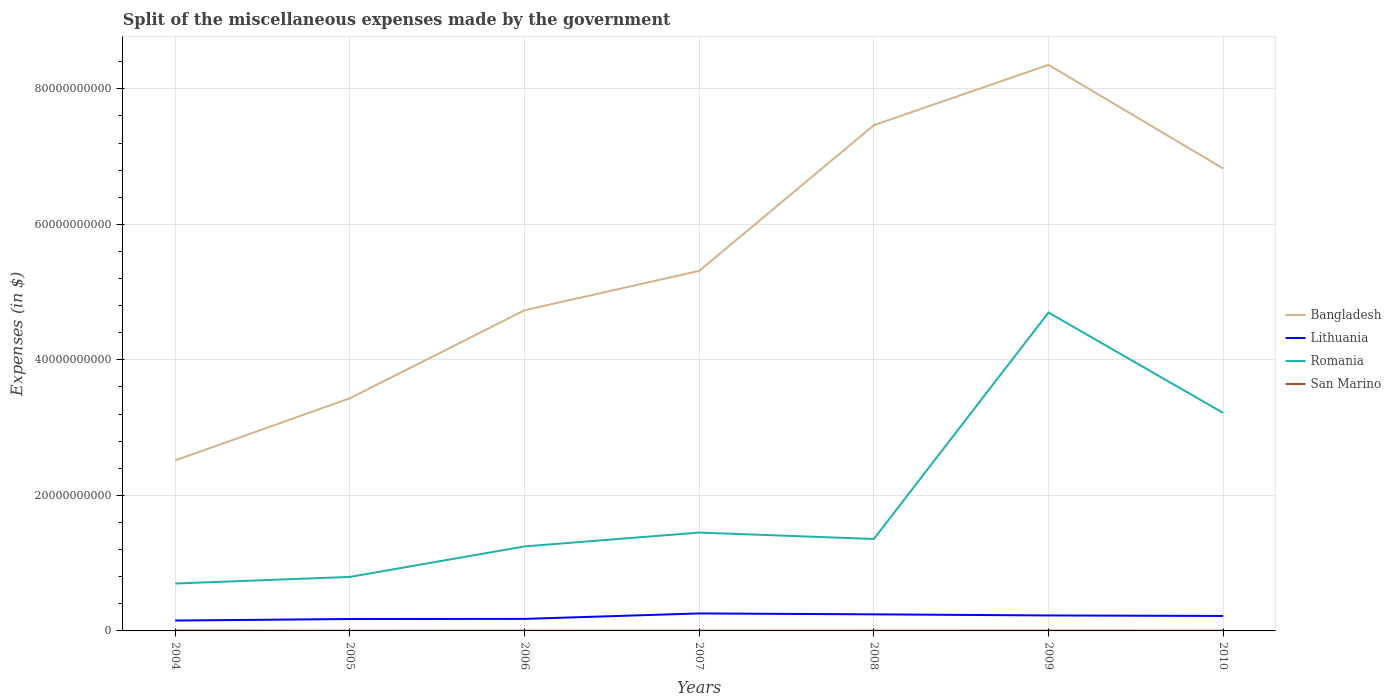How many different coloured lines are there?
Give a very brief answer. 4. Does the line corresponding to San Marino intersect with the line corresponding to Romania?
Provide a succinct answer. No. Is the number of lines equal to the number of legend labels?
Offer a terse response. Yes. Across all years, what is the maximum miscellaneous expenses made by the government in Bangladesh?
Offer a terse response. 2.52e+1. In which year was the miscellaneous expenses made by the government in Lithuania maximum?
Provide a succinct answer. 2004. What is the total miscellaneous expenses made by the government in Lithuania in the graph?
Offer a very short reply. -8.07e+08. What is the difference between the highest and the second highest miscellaneous expenses made by the government in San Marino?
Keep it short and to the point. 2.70e+07. What is the difference between the highest and the lowest miscellaneous expenses made by the government in Lithuania?
Your answer should be very brief. 4. How many lines are there?
Provide a succinct answer. 4. Does the graph contain any zero values?
Your answer should be very brief. No. Does the graph contain grids?
Give a very brief answer. Yes. How are the legend labels stacked?
Your response must be concise. Vertical. What is the title of the graph?
Give a very brief answer. Split of the miscellaneous expenses made by the government. What is the label or title of the X-axis?
Your answer should be compact. Years. What is the label or title of the Y-axis?
Your answer should be very brief. Expenses (in $). What is the Expenses (in $) of Bangladesh in 2004?
Your answer should be very brief. 2.52e+1. What is the Expenses (in $) in Lithuania in 2004?
Give a very brief answer. 1.53e+09. What is the Expenses (in $) in Romania in 2004?
Offer a very short reply. 6.99e+09. What is the Expenses (in $) in San Marino in 2004?
Your answer should be very brief. 5.65e+07. What is the Expenses (in $) of Bangladesh in 2005?
Make the answer very short. 3.43e+1. What is the Expenses (in $) of Lithuania in 2005?
Offer a terse response. 1.75e+09. What is the Expenses (in $) of Romania in 2005?
Provide a short and direct response. 7.97e+09. What is the Expenses (in $) in San Marino in 2005?
Offer a terse response. 2.95e+07. What is the Expenses (in $) of Bangladesh in 2006?
Give a very brief answer. 4.73e+1. What is the Expenses (in $) of Lithuania in 2006?
Your answer should be very brief. 1.78e+09. What is the Expenses (in $) of Romania in 2006?
Your response must be concise. 1.25e+1. What is the Expenses (in $) of San Marino in 2006?
Offer a terse response. 3.73e+07. What is the Expenses (in $) of Bangladesh in 2007?
Your answer should be very brief. 5.31e+1. What is the Expenses (in $) in Lithuania in 2007?
Your answer should be compact. 2.58e+09. What is the Expenses (in $) in Romania in 2007?
Offer a terse response. 1.45e+1. What is the Expenses (in $) of San Marino in 2007?
Your answer should be compact. 3.50e+07. What is the Expenses (in $) of Bangladesh in 2008?
Keep it short and to the point. 7.46e+1. What is the Expenses (in $) in Lithuania in 2008?
Your response must be concise. 2.45e+09. What is the Expenses (in $) of Romania in 2008?
Your answer should be compact. 1.36e+1. What is the Expenses (in $) in San Marino in 2008?
Your answer should be compact. 3.81e+07. What is the Expenses (in $) in Bangladesh in 2009?
Make the answer very short. 8.35e+1. What is the Expenses (in $) in Lithuania in 2009?
Provide a succinct answer. 2.28e+09. What is the Expenses (in $) in Romania in 2009?
Give a very brief answer. 4.70e+1. What is the Expenses (in $) in San Marino in 2009?
Your response must be concise. 4.16e+07. What is the Expenses (in $) in Bangladesh in 2010?
Offer a very short reply. 6.82e+1. What is the Expenses (in $) of Lithuania in 2010?
Provide a succinct answer. 2.21e+09. What is the Expenses (in $) of Romania in 2010?
Give a very brief answer. 3.22e+1. What is the Expenses (in $) in San Marino in 2010?
Your response must be concise. 4.00e+07. Across all years, what is the maximum Expenses (in $) in Bangladesh?
Keep it short and to the point. 8.35e+1. Across all years, what is the maximum Expenses (in $) in Lithuania?
Keep it short and to the point. 2.58e+09. Across all years, what is the maximum Expenses (in $) in Romania?
Provide a short and direct response. 4.70e+1. Across all years, what is the maximum Expenses (in $) of San Marino?
Make the answer very short. 5.65e+07. Across all years, what is the minimum Expenses (in $) in Bangladesh?
Your answer should be compact. 2.52e+1. Across all years, what is the minimum Expenses (in $) of Lithuania?
Your response must be concise. 1.53e+09. Across all years, what is the minimum Expenses (in $) of Romania?
Provide a short and direct response. 6.99e+09. Across all years, what is the minimum Expenses (in $) of San Marino?
Your answer should be very brief. 2.95e+07. What is the total Expenses (in $) of Bangladesh in the graph?
Ensure brevity in your answer.  3.86e+11. What is the total Expenses (in $) in Lithuania in the graph?
Offer a very short reply. 1.46e+1. What is the total Expenses (in $) in Romania in the graph?
Offer a very short reply. 1.35e+11. What is the total Expenses (in $) of San Marino in the graph?
Make the answer very short. 2.78e+08. What is the difference between the Expenses (in $) of Bangladesh in 2004 and that in 2005?
Offer a terse response. -9.17e+09. What is the difference between the Expenses (in $) in Lithuania in 2004 and that in 2005?
Keep it short and to the point. -2.23e+08. What is the difference between the Expenses (in $) of Romania in 2004 and that in 2005?
Offer a very short reply. -9.76e+08. What is the difference between the Expenses (in $) of San Marino in 2004 and that in 2005?
Make the answer very short. 2.70e+07. What is the difference between the Expenses (in $) of Bangladesh in 2004 and that in 2006?
Your response must be concise. -2.22e+1. What is the difference between the Expenses (in $) in Lithuania in 2004 and that in 2006?
Provide a short and direct response. -2.45e+08. What is the difference between the Expenses (in $) in Romania in 2004 and that in 2006?
Provide a short and direct response. -5.48e+09. What is the difference between the Expenses (in $) of San Marino in 2004 and that in 2006?
Provide a succinct answer. 1.92e+07. What is the difference between the Expenses (in $) of Bangladesh in 2004 and that in 2007?
Offer a terse response. -2.80e+1. What is the difference between the Expenses (in $) of Lithuania in 2004 and that in 2007?
Provide a succinct answer. -1.05e+09. What is the difference between the Expenses (in $) of Romania in 2004 and that in 2007?
Your answer should be compact. -7.52e+09. What is the difference between the Expenses (in $) of San Marino in 2004 and that in 2007?
Your response must be concise. 2.15e+07. What is the difference between the Expenses (in $) of Bangladesh in 2004 and that in 2008?
Provide a succinct answer. -4.95e+1. What is the difference between the Expenses (in $) in Lithuania in 2004 and that in 2008?
Make the answer very short. -9.16e+08. What is the difference between the Expenses (in $) in Romania in 2004 and that in 2008?
Make the answer very short. -6.57e+09. What is the difference between the Expenses (in $) in San Marino in 2004 and that in 2008?
Your answer should be very brief. 1.83e+07. What is the difference between the Expenses (in $) of Bangladesh in 2004 and that in 2009?
Offer a terse response. -5.84e+1. What is the difference between the Expenses (in $) in Lithuania in 2004 and that in 2009?
Provide a succinct answer. -7.53e+08. What is the difference between the Expenses (in $) of Romania in 2004 and that in 2009?
Keep it short and to the point. -4.00e+1. What is the difference between the Expenses (in $) of San Marino in 2004 and that in 2009?
Ensure brevity in your answer.  1.49e+07. What is the difference between the Expenses (in $) of Bangladesh in 2004 and that in 2010?
Ensure brevity in your answer.  -4.31e+1. What is the difference between the Expenses (in $) of Lithuania in 2004 and that in 2010?
Your response must be concise. -6.78e+08. What is the difference between the Expenses (in $) of Romania in 2004 and that in 2010?
Provide a succinct answer. -2.52e+1. What is the difference between the Expenses (in $) in San Marino in 2004 and that in 2010?
Provide a short and direct response. 1.65e+07. What is the difference between the Expenses (in $) in Bangladesh in 2005 and that in 2006?
Your answer should be compact. -1.30e+1. What is the difference between the Expenses (in $) of Lithuania in 2005 and that in 2006?
Offer a terse response. -2.16e+07. What is the difference between the Expenses (in $) in Romania in 2005 and that in 2006?
Your answer should be compact. -4.50e+09. What is the difference between the Expenses (in $) in San Marino in 2005 and that in 2006?
Your answer should be compact. -7.72e+06. What is the difference between the Expenses (in $) in Bangladesh in 2005 and that in 2007?
Your response must be concise. -1.88e+1. What is the difference between the Expenses (in $) of Lithuania in 2005 and that in 2007?
Your answer should be very brief. -8.28e+08. What is the difference between the Expenses (in $) of Romania in 2005 and that in 2007?
Ensure brevity in your answer.  -6.55e+09. What is the difference between the Expenses (in $) in San Marino in 2005 and that in 2007?
Provide a short and direct response. -5.46e+06. What is the difference between the Expenses (in $) of Bangladesh in 2005 and that in 2008?
Your answer should be very brief. -4.03e+1. What is the difference between the Expenses (in $) of Lithuania in 2005 and that in 2008?
Ensure brevity in your answer.  -6.93e+08. What is the difference between the Expenses (in $) in Romania in 2005 and that in 2008?
Make the answer very short. -5.60e+09. What is the difference between the Expenses (in $) of San Marino in 2005 and that in 2008?
Your answer should be very brief. -8.61e+06. What is the difference between the Expenses (in $) in Bangladesh in 2005 and that in 2009?
Your response must be concise. -4.92e+1. What is the difference between the Expenses (in $) in Lithuania in 2005 and that in 2009?
Provide a short and direct response. -5.29e+08. What is the difference between the Expenses (in $) of Romania in 2005 and that in 2009?
Keep it short and to the point. -3.90e+1. What is the difference between the Expenses (in $) of San Marino in 2005 and that in 2009?
Make the answer very short. -1.21e+07. What is the difference between the Expenses (in $) of Bangladesh in 2005 and that in 2010?
Offer a terse response. -3.39e+1. What is the difference between the Expenses (in $) of Lithuania in 2005 and that in 2010?
Ensure brevity in your answer.  -4.54e+08. What is the difference between the Expenses (in $) of Romania in 2005 and that in 2010?
Give a very brief answer. -2.42e+1. What is the difference between the Expenses (in $) in San Marino in 2005 and that in 2010?
Provide a short and direct response. -1.05e+07. What is the difference between the Expenses (in $) in Bangladesh in 2006 and that in 2007?
Your answer should be compact. -5.81e+09. What is the difference between the Expenses (in $) in Lithuania in 2006 and that in 2007?
Make the answer very short. -8.07e+08. What is the difference between the Expenses (in $) of Romania in 2006 and that in 2007?
Provide a succinct answer. -2.04e+09. What is the difference between the Expenses (in $) of San Marino in 2006 and that in 2007?
Your answer should be compact. 2.26e+06. What is the difference between the Expenses (in $) of Bangladesh in 2006 and that in 2008?
Your answer should be very brief. -2.73e+1. What is the difference between the Expenses (in $) in Lithuania in 2006 and that in 2008?
Your answer should be very brief. -6.71e+08. What is the difference between the Expenses (in $) of Romania in 2006 and that in 2008?
Ensure brevity in your answer.  -1.10e+09. What is the difference between the Expenses (in $) in San Marino in 2006 and that in 2008?
Your answer should be very brief. -8.90e+05. What is the difference between the Expenses (in $) of Bangladesh in 2006 and that in 2009?
Your response must be concise. -3.62e+1. What is the difference between the Expenses (in $) in Lithuania in 2006 and that in 2009?
Your answer should be compact. -5.08e+08. What is the difference between the Expenses (in $) of Romania in 2006 and that in 2009?
Offer a very short reply. -3.45e+1. What is the difference between the Expenses (in $) in San Marino in 2006 and that in 2009?
Your response must be concise. -4.37e+06. What is the difference between the Expenses (in $) in Bangladesh in 2006 and that in 2010?
Your answer should be compact. -2.09e+1. What is the difference between the Expenses (in $) in Lithuania in 2006 and that in 2010?
Provide a short and direct response. -4.33e+08. What is the difference between the Expenses (in $) of Romania in 2006 and that in 2010?
Your answer should be compact. -1.97e+1. What is the difference between the Expenses (in $) in San Marino in 2006 and that in 2010?
Ensure brevity in your answer.  -2.76e+06. What is the difference between the Expenses (in $) of Bangladesh in 2007 and that in 2008?
Offer a very short reply. -2.15e+1. What is the difference between the Expenses (in $) in Lithuania in 2007 and that in 2008?
Make the answer very short. 1.36e+08. What is the difference between the Expenses (in $) in Romania in 2007 and that in 2008?
Make the answer very short. 9.48e+08. What is the difference between the Expenses (in $) of San Marino in 2007 and that in 2008?
Keep it short and to the point. -3.15e+06. What is the difference between the Expenses (in $) in Bangladesh in 2007 and that in 2009?
Make the answer very short. -3.04e+1. What is the difference between the Expenses (in $) of Lithuania in 2007 and that in 2009?
Keep it short and to the point. 2.99e+08. What is the difference between the Expenses (in $) of Romania in 2007 and that in 2009?
Make the answer very short. -3.25e+1. What is the difference between the Expenses (in $) of San Marino in 2007 and that in 2009?
Keep it short and to the point. -6.63e+06. What is the difference between the Expenses (in $) in Bangladesh in 2007 and that in 2010?
Your answer should be compact. -1.51e+1. What is the difference between the Expenses (in $) in Lithuania in 2007 and that in 2010?
Your answer should be very brief. 3.74e+08. What is the difference between the Expenses (in $) in Romania in 2007 and that in 2010?
Your answer should be very brief. -1.77e+1. What is the difference between the Expenses (in $) of San Marino in 2007 and that in 2010?
Offer a very short reply. -5.02e+06. What is the difference between the Expenses (in $) of Bangladesh in 2008 and that in 2009?
Give a very brief answer. -8.90e+09. What is the difference between the Expenses (in $) of Lithuania in 2008 and that in 2009?
Make the answer very short. 1.64e+08. What is the difference between the Expenses (in $) of Romania in 2008 and that in 2009?
Provide a short and direct response. -3.34e+1. What is the difference between the Expenses (in $) in San Marino in 2008 and that in 2009?
Give a very brief answer. -3.48e+06. What is the difference between the Expenses (in $) in Bangladesh in 2008 and that in 2010?
Make the answer very short. 6.39e+09. What is the difference between the Expenses (in $) in Lithuania in 2008 and that in 2010?
Your answer should be compact. 2.38e+08. What is the difference between the Expenses (in $) in Romania in 2008 and that in 2010?
Give a very brief answer. -1.86e+1. What is the difference between the Expenses (in $) of San Marino in 2008 and that in 2010?
Offer a very short reply. -1.87e+06. What is the difference between the Expenses (in $) of Bangladesh in 2009 and that in 2010?
Provide a short and direct response. 1.53e+1. What is the difference between the Expenses (in $) of Lithuania in 2009 and that in 2010?
Offer a very short reply. 7.48e+07. What is the difference between the Expenses (in $) in Romania in 2009 and that in 2010?
Provide a short and direct response. 1.48e+1. What is the difference between the Expenses (in $) in San Marino in 2009 and that in 2010?
Make the answer very short. 1.61e+06. What is the difference between the Expenses (in $) of Bangladesh in 2004 and the Expenses (in $) of Lithuania in 2005?
Your response must be concise. 2.34e+1. What is the difference between the Expenses (in $) in Bangladesh in 2004 and the Expenses (in $) in Romania in 2005?
Your response must be concise. 1.72e+1. What is the difference between the Expenses (in $) of Bangladesh in 2004 and the Expenses (in $) of San Marino in 2005?
Offer a terse response. 2.51e+1. What is the difference between the Expenses (in $) in Lithuania in 2004 and the Expenses (in $) in Romania in 2005?
Offer a terse response. -6.44e+09. What is the difference between the Expenses (in $) in Lithuania in 2004 and the Expenses (in $) in San Marino in 2005?
Give a very brief answer. 1.50e+09. What is the difference between the Expenses (in $) of Romania in 2004 and the Expenses (in $) of San Marino in 2005?
Your answer should be compact. 6.96e+09. What is the difference between the Expenses (in $) of Bangladesh in 2004 and the Expenses (in $) of Lithuania in 2006?
Provide a short and direct response. 2.34e+1. What is the difference between the Expenses (in $) in Bangladesh in 2004 and the Expenses (in $) in Romania in 2006?
Offer a terse response. 1.27e+1. What is the difference between the Expenses (in $) in Bangladesh in 2004 and the Expenses (in $) in San Marino in 2006?
Keep it short and to the point. 2.51e+1. What is the difference between the Expenses (in $) of Lithuania in 2004 and the Expenses (in $) of Romania in 2006?
Offer a very short reply. -1.09e+1. What is the difference between the Expenses (in $) of Lithuania in 2004 and the Expenses (in $) of San Marino in 2006?
Offer a terse response. 1.49e+09. What is the difference between the Expenses (in $) of Romania in 2004 and the Expenses (in $) of San Marino in 2006?
Offer a very short reply. 6.96e+09. What is the difference between the Expenses (in $) in Bangladesh in 2004 and the Expenses (in $) in Lithuania in 2007?
Provide a succinct answer. 2.26e+1. What is the difference between the Expenses (in $) of Bangladesh in 2004 and the Expenses (in $) of Romania in 2007?
Keep it short and to the point. 1.06e+1. What is the difference between the Expenses (in $) in Bangladesh in 2004 and the Expenses (in $) in San Marino in 2007?
Your answer should be compact. 2.51e+1. What is the difference between the Expenses (in $) of Lithuania in 2004 and the Expenses (in $) of Romania in 2007?
Keep it short and to the point. -1.30e+1. What is the difference between the Expenses (in $) of Lithuania in 2004 and the Expenses (in $) of San Marino in 2007?
Make the answer very short. 1.50e+09. What is the difference between the Expenses (in $) in Romania in 2004 and the Expenses (in $) in San Marino in 2007?
Your answer should be compact. 6.96e+09. What is the difference between the Expenses (in $) of Bangladesh in 2004 and the Expenses (in $) of Lithuania in 2008?
Offer a very short reply. 2.27e+1. What is the difference between the Expenses (in $) in Bangladesh in 2004 and the Expenses (in $) in Romania in 2008?
Your answer should be compact. 1.16e+1. What is the difference between the Expenses (in $) in Bangladesh in 2004 and the Expenses (in $) in San Marino in 2008?
Your answer should be very brief. 2.51e+1. What is the difference between the Expenses (in $) in Lithuania in 2004 and the Expenses (in $) in Romania in 2008?
Ensure brevity in your answer.  -1.20e+1. What is the difference between the Expenses (in $) of Lithuania in 2004 and the Expenses (in $) of San Marino in 2008?
Provide a succinct answer. 1.49e+09. What is the difference between the Expenses (in $) in Romania in 2004 and the Expenses (in $) in San Marino in 2008?
Provide a succinct answer. 6.96e+09. What is the difference between the Expenses (in $) in Bangladesh in 2004 and the Expenses (in $) in Lithuania in 2009?
Offer a terse response. 2.29e+1. What is the difference between the Expenses (in $) of Bangladesh in 2004 and the Expenses (in $) of Romania in 2009?
Offer a terse response. -2.18e+1. What is the difference between the Expenses (in $) of Bangladesh in 2004 and the Expenses (in $) of San Marino in 2009?
Make the answer very short. 2.51e+1. What is the difference between the Expenses (in $) of Lithuania in 2004 and the Expenses (in $) of Romania in 2009?
Offer a terse response. -4.55e+1. What is the difference between the Expenses (in $) of Lithuania in 2004 and the Expenses (in $) of San Marino in 2009?
Your answer should be very brief. 1.49e+09. What is the difference between the Expenses (in $) of Romania in 2004 and the Expenses (in $) of San Marino in 2009?
Provide a succinct answer. 6.95e+09. What is the difference between the Expenses (in $) in Bangladesh in 2004 and the Expenses (in $) in Lithuania in 2010?
Offer a very short reply. 2.30e+1. What is the difference between the Expenses (in $) in Bangladesh in 2004 and the Expenses (in $) in Romania in 2010?
Your response must be concise. -7.01e+09. What is the difference between the Expenses (in $) in Bangladesh in 2004 and the Expenses (in $) in San Marino in 2010?
Your answer should be compact. 2.51e+1. What is the difference between the Expenses (in $) in Lithuania in 2004 and the Expenses (in $) in Romania in 2010?
Your answer should be compact. -3.06e+1. What is the difference between the Expenses (in $) of Lithuania in 2004 and the Expenses (in $) of San Marino in 2010?
Provide a succinct answer. 1.49e+09. What is the difference between the Expenses (in $) in Romania in 2004 and the Expenses (in $) in San Marino in 2010?
Ensure brevity in your answer.  6.95e+09. What is the difference between the Expenses (in $) in Bangladesh in 2005 and the Expenses (in $) in Lithuania in 2006?
Your answer should be compact. 3.26e+1. What is the difference between the Expenses (in $) in Bangladesh in 2005 and the Expenses (in $) in Romania in 2006?
Offer a very short reply. 2.19e+1. What is the difference between the Expenses (in $) of Bangladesh in 2005 and the Expenses (in $) of San Marino in 2006?
Your answer should be compact. 3.43e+1. What is the difference between the Expenses (in $) in Lithuania in 2005 and the Expenses (in $) in Romania in 2006?
Ensure brevity in your answer.  -1.07e+1. What is the difference between the Expenses (in $) in Lithuania in 2005 and the Expenses (in $) in San Marino in 2006?
Provide a short and direct response. 1.72e+09. What is the difference between the Expenses (in $) of Romania in 2005 and the Expenses (in $) of San Marino in 2006?
Offer a very short reply. 7.93e+09. What is the difference between the Expenses (in $) in Bangladesh in 2005 and the Expenses (in $) in Lithuania in 2007?
Keep it short and to the point. 3.18e+1. What is the difference between the Expenses (in $) of Bangladesh in 2005 and the Expenses (in $) of Romania in 2007?
Your answer should be very brief. 1.98e+1. What is the difference between the Expenses (in $) in Bangladesh in 2005 and the Expenses (in $) in San Marino in 2007?
Offer a terse response. 3.43e+1. What is the difference between the Expenses (in $) of Lithuania in 2005 and the Expenses (in $) of Romania in 2007?
Provide a short and direct response. -1.28e+1. What is the difference between the Expenses (in $) in Lithuania in 2005 and the Expenses (in $) in San Marino in 2007?
Give a very brief answer. 1.72e+09. What is the difference between the Expenses (in $) of Romania in 2005 and the Expenses (in $) of San Marino in 2007?
Give a very brief answer. 7.94e+09. What is the difference between the Expenses (in $) of Bangladesh in 2005 and the Expenses (in $) of Lithuania in 2008?
Give a very brief answer. 3.19e+1. What is the difference between the Expenses (in $) of Bangladesh in 2005 and the Expenses (in $) of Romania in 2008?
Ensure brevity in your answer.  2.08e+1. What is the difference between the Expenses (in $) in Bangladesh in 2005 and the Expenses (in $) in San Marino in 2008?
Provide a succinct answer. 3.43e+1. What is the difference between the Expenses (in $) of Lithuania in 2005 and the Expenses (in $) of Romania in 2008?
Your answer should be very brief. -1.18e+1. What is the difference between the Expenses (in $) in Lithuania in 2005 and the Expenses (in $) in San Marino in 2008?
Make the answer very short. 1.72e+09. What is the difference between the Expenses (in $) in Romania in 2005 and the Expenses (in $) in San Marino in 2008?
Keep it short and to the point. 7.93e+09. What is the difference between the Expenses (in $) of Bangladesh in 2005 and the Expenses (in $) of Lithuania in 2009?
Keep it short and to the point. 3.21e+1. What is the difference between the Expenses (in $) of Bangladesh in 2005 and the Expenses (in $) of Romania in 2009?
Your response must be concise. -1.26e+1. What is the difference between the Expenses (in $) in Bangladesh in 2005 and the Expenses (in $) in San Marino in 2009?
Provide a short and direct response. 3.43e+1. What is the difference between the Expenses (in $) of Lithuania in 2005 and the Expenses (in $) of Romania in 2009?
Offer a very short reply. -4.52e+1. What is the difference between the Expenses (in $) of Lithuania in 2005 and the Expenses (in $) of San Marino in 2009?
Your answer should be compact. 1.71e+09. What is the difference between the Expenses (in $) of Romania in 2005 and the Expenses (in $) of San Marino in 2009?
Your response must be concise. 7.93e+09. What is the difference between the Expenses (in $) in Bangladesh in 2005 and the Expenses (in $) in Lithuania in 2010?
Make the answer very short. 3.21e+1. What is the difference between the Expenses (in $) in Bangladesh in 2005 and the Expenses (in $) in Romania in 2010?
Your response must be concise. 2.16e+09. What is the difference between the Expenses (in $) of Bangladesh in 2005 and the Expenses (in $) of San Marino in 2010?
Make the answer very short. 3.43e+1. What is the difference between the Expenses (in $) in Lithuania in 2005 and the Expenses (in $) in Romania in 2010?
Give a very brief answer. -3.04e+1. What is the difference between the Expenses (in $) of Lithuania in 2005 and the Expenses (in $) of San Marino in 2010?
Make the answer very short. 1.71e+09. What is the difference between the Expenses (in $) in Romania in 2005 and the Expenses (in $) in San Marino in 2010?
Provide a succinct answer. 7.93e+09. What is the difference between the Expenses (in $) in Bangladesh in 2006 and the Expenses (in $) in Lithuania in 2007?
Your response must be concise. 4.47e+1. What is the difference between the Expenses (in $) of Bangladesh in 2006 and the Expenses (in $) of Romania in 2007?
Offer a very short reply. 3.28e+1. What is the difference between the Expenses (in $) in Bangladesh in 2006 and the Expenses (in $) in San Marino in 2007?
Give a very brief answer. 4.73e+1. What is the difference between the Expenses (in $) of Lithuania in 2006 and the Expenses (in $) of Romania in 2007?
Keep it short and to the point. -1.27e+1. What is the difference between the Expenses (in $) of Lithuania in 2006 and the Expenses (in $) of San Marino in 2007?
Ensure brevity in your answer.  1.74e+09. What is the difference between the Expenses (in $) of Romania in 2006 and the Expenses (in $) of San Marino in 2007?
Give a very brief answer. 1.24e+1. What is the difference between the Expenses (in $) in Bangladesh in 2006 and the Expenses (in $) in Lithuania in 2008?
Provide a short and direct response. 4.49e+1. What is the difference between the Expenses (in $) of Bangladesh in 2006 and the Expenses (in $) of Romania in 2008?
Your answer should be compact. 3.38e+1. What is the difference between the Expenses (in $) in Bangladesh in 2006 and the Expenses (in $) in San Marino in 2008?
Your response must be concise. 4.73e+1. What is the difference between the Expenses (in $) in Lithuania in 2006 and the Expenses (in $) in Romania in 2008?
Ensure brevity in your answer.  -1.18e+1. What is the difference between the Expenses (in $) in Lithuania in 2006 and the Expenses (in $) in San Marino in 2008?
Provide a short and direct response. 1.74e+09. What is the difference between the Expenses (in $) in Romania in 2006 and the Expenses (in $) in San Marino in 2008?
Make the answer very short. 1.24e+1. What is the difference between the Expenses (in $) in Bangladesh in 2006 and the Expenses (in $) in Lithuania in 2009?
Provide a succinct answer. 4.50e+1. What is the difference between the Expenses (in $) of Bangladesh in 2006 and the Expenses (in $) of Romania in 2009?
Your answer should be very brief. 3.41e+08. What is the difference between the Expenses (in $) of Bangladesh in 2006 and the Expenses (in $) of San Marino in 2009?
Offer a very short reply. 4.73e+1. What is the difference between the Expenses (in $) in Lithuania in 2006 and the Expenses (in $) in Romania in 2009?
Ensure brevity in your answer.  -4.52e+1. What is the difference between the Expenses (in $) in Lithuania in 2006 and the Expenses (in $) in San Marino in 2009?
Your answer should be compact. 1.73e+09. What is the difference between the Expenses (in $) in Romania in 2006 and the Expenses (in $) in San Marino in 2009?
Give a very brief answer. 1.24e+1. What is the difference between the Expenses (in $) of Bangladesh in 2006 and the Expenses (in $) of Lithuania in 2010?
Offer a terse response. 4.51e+1. What is the difference between the Expenses (in $) of Bangladesh in 2006 and the Expenses (in $) of Romania in 2010?
Your answer should be very brief. 1.51e+1. What is the difference between the Expenses (in $) in Bangladesh in 2006 and the Expenses (in $) in San Marino in 2010?
Make the answer very short. 4.73e+1. What is the difference between the Expenses (in $) of Lithuania in 2006 and the Expenses (in $) of Romania in 2010?
Offer a very short reply. -3.04e+1. What is the difference between the Expenses (in $) in Lithuania in 2006 and the Expenses (in $) in San Marino in 2010?
Your answer should be compact. 1.74e+09. What is the difference between the Expenses (in $) in Romania in 2006 and the Expenses (in $) in San Marino in 2010?
Keep it short and to the point. 1.24e+1. What is the difference between the Expenses (in $) in Bangladesh in 2007 and the Expenses (in $) in Lithuania in 2008?
Your answer should be very brief. 5.07e+1. What is the difference between the Expenses (in $) in Bangladesh in 2007 and the Expenses (in $) in Romania in 2008?
Offer a very short reply. 3.96e+1. What is the difference between the Expenses (in $) of Bangladesh in 2007 and the Expenses (in $) of San Marino in 2008?
Your response must be concise. 5.31e+1. What is the difference between the Expenses (in $) in Lithuania in 2007 and the Expenses (in $) in Romania in 2008?
Ensure brevity in your answer.  -1.10e+1. What is the difference between the Expenses (in $) of Lithuania in 2007 and the Expenses (in $) of San Marino in 2008?
Give a very brief answer. 2.54e+09. What is the difference between the Expenses (in $) in Romania in 2007 and the Expenses (in $) in San Marino in 2008?
Your response must be concise. 1.45e+1. What is the difference between the Expenses (in $) in Bangladesh in 2007 and the Expenses (in $) in Lithuania in 2009?
Ensure brevity in your answer.  5.08e+1. What is the difference between the Expenses (in $) of Bangladesh in 2007 and the Expenses (in $) of Romania in 2009?
Provide a succinct answer. 6.15e+09. What is the difference between the Expenses (in $) in Bangladesh in 2007 and the Expenses (in $) in San Marino in 2009?
Provide a short and direct response. 5.31e+1. What is the difference between the Expenses (in $) in Lithuania in 2007 and the Expenses (in $) in Romania in 2009?
Offer a very short reply. -4.44e+1. What is the difference between the Expenses (in $) in Lithuania in 2007 and the Expenses (in $) in San Marino in 2009?
Offer a very short reply. 2.54e+09. What is the difference between the Expenses (in $) in Romania in 2007 and the Expenses (in $) in San Marino in 2009?
Your answer should be compact. 1.45e+1. What is the difference between the Expenses (in $) in Bangladesh in 2007 and the Expenses (in $) in Lithuania in 2010?
Give a very brief answer. 5.09e+1. What is the difference between the Expenses (in $) in Bangladesh in 2007 and the Expenses (in $) in Romania in 2010?
Your response must be concise. 2.10e+1. What is the difference between the Expenses (in $) in Bangladesh in 2007 and the Expenses (in $) in San Marino in 2010?
Your answer should be compact. 5.31e+1. What is the difference between the Expenses (in $) of Lithuania in 2007 and the Expenses (in $) of Romania in 2010?
Your answer should be compact. -2.96e+1. What is the difference between the Expenses (in $) of Lithuania in 2007 and the Expenses (in $) of San Marino in 2010?
Give a very brief answer. 2.54e+09. What is the difference between the Expenses (in $) in Romania in 2007 and the Expenses (in $) in San Marino in 2010?
Provide a succinct answer. 1.45e+1. What is the difference between the Expenses (in $) of Bangladesh in 2008 and the Expenses (in $) of Lithuania in 2009?
Your response must be concise. 7.24e+1. What is the difference between the Expenses (in $) of Bangladesh in 2008 and the Expenses (in $) of Romania in 2009?
Provide a short and direct response. 2.77e+1. What is the difference between the Expenses (in $) of Bangladesh in 2008 and the Expenses (in $) of San Marino in 2009?
Give a very brief answer. 7.46e+1. What is the difference between the Expenses (in $) in Lithuania in 2008 and the Expenses (in $) in Romania in 2009?
Provide a short and direct response. -4.45e+1. What is the difference between the Expenses (in $) in Lithuania in 2008 and the Expenses (in $) in San Marino in 2009?
Keep it short and to the point. 2.41e+09. What is the difference between the Expenses (in $) of Romania in 2008 and the Expenses (in $) of San Marino in 2009?
Provide a short and direct response. 1.35e+1. What is the difference between the Expenses (in $) in Bangladesh in 2008 and the Expenses (in $) in Lithuania in 2010?
Keep it short and to the point. 7.24e+1. What is the difference between the Expenses (in $) in Bangladesh in 2008 and the Expenses (in $) in Romania in 2010?
Your response must be concise. 4.25e+1. What is the difference between the Expenses (in $) of Bangladesh in 2008 and the Expenses (in $) of San Marino in 2010?
Make the answer very short. 7.46e+1. What is the difference between the Expenses (in $) in Lithuania in 2008 and the Expenses (in $) in Romania in 2010?
Your answer should be very brief. -2.97e+1. What is the difference between the Expenses (in $) in Lithuania in 2008 and the Expenses (in $) in San Marino in 2010?
Offer a very short reply. 2.41e+09. What is the difference between the Expenses (in $) in Romania in 2008 and the Expenses (in $) in San Marino in 2010?
Keep it short and to the point. 1.35e+1. What is the difference between the Expenses (in $) of Bangladesh in 2009 and the Expenses (in $) of Lithuania in 2010?
Give a very brief answer. 8.13e+1. What is the difference between the Expenses (in $) of Bangladesh in 2009 and the Expenses (in $) of Romania in 2010?
Provide a succinct answer. 5.14e+1. What is the difference between the Expenses (in $) of Bangladesh in 2009 and the Expenses (in $) of San Marino in 2010?
Ensure brevity in your answer.  8.35e+1. What is the difference between the Expenses (in $) of Lithuania in 2009 and the Expenses (in $) of Romania in 2010?
Your answer should be very brief. -2.99e+1. What is the difference between the Expenses (in $) in Lithuania in 2009 and the Expenses (in $) in San Marino in 2010?
Provide a short and direct response. 2.24e+09. What is the difference between the Expenses (in $) in Romania in 2009 and the Expenses (in $) in San Marino in 2010?
Ensure brevity in your answer.  4.69e+1. What is the average Expenses (in $) in Bangladesh per year?
Offer a very short reply. 5.52e+1. What is the average Expenses (in $) in Lithuania per year?
Give a very brief answer. 2.08e+09. What is the average Expenses (in $) in Romania per year?
Give a very brief answer. 1.92e+1. What is the average Expenses (in $) of San Marino per year?
Provide a succinct answer. 3.97e+07. In the year 2004, what is the difference between the Expenses (in $) in Bangladesh and Expenses (in $) in Lithuania?
Ensure brevity in your answer.  2.36e+1. In the year 2004, what is the difference between the Expenses (in $) in Bangladesh and Expenses (in $) in Romania?
Make the answer very short. 1.82e+1. In the year 2004, what is the difference between the Expenses (in $) of Bangladesh and Expenses (in $) of San Marino?
Your answer should be compact. 2.51e+1. In the year 2004, what is the difference between the Expenses (in $) of Lithuania and Expenses (in $) of Romania?
Give a very brief answer. -5.46e+09. In the year 2004, what is the difference between the Expenses (in $) of Lithuania and Expenses (in $) of San Marino?
Make the answer very short. 1.47e+09. In the year 2004, what is the difference between the Expenses (in $) in Romania and Expenses (in $) in San Marino?
Your response must be concise. 6.94e+09. In the year 2005, what is the difference between the Expenses (in $) of Bangladesh and Expenses (in $) of Lithuania?
Make the answer very short. 3.26e+1. In the year 2005, what is the difference between the Expenses (in $) in Bangladesh and Expenses (in $) in Romania?
Your answer should be compact. 2.64e+1. In the year 2005, what is the difference between the Expenses (in $) of Bangladesh and Expenses (in $) of San Marino?
Ensure brevity in your answer.  3.43e+1. In the year 2005, what is the difference between the Expenses (in $) of Lithuania and Expenses (in $) of Romania?
Your response must be concise. -6.22e+09. In the year 2005, what is the difference between the Expenses (in $) in Lithuania and Expenses (in $) in San Marino?
Give a very brief answer. 1.72e+09. In the year 2005, what is the difference between the Expenses (in $) of Romania and Expenses (in $) of San Marino?
Your answer should be very brief. 7.94e+09. In the year 2006, what is the difference between the Expenses (in $) in Bangladesh and Expenses (in $) in Lithuania?
Provide a succinct answer. 4.55e+1. In the year 2006, what is the difference between the Expenses (in $) of Bangladesh and Expenses (in $) of Romania?
Your response must be concise. 3.49e+1. In the year 2006, what is the difference between the Expenses (in $) in Bangladesh and Expenses (in $) in San Marino?
Provide a short and direct response. 4.73e+1. In the year 2006, what is the difference between the Expenses (in $) in Lithuania and Expenses (in $) in Romania?
Ensure brevity in your answer.  -1.07e+1. In the year 2006, what is the difference between the Expenses (in $) in Lithuania and Expenses (in $) in San Marino?
Keep it short and to the point. 1.74e+09. In the year 2006, what is the difference between the Expenses (in $) of Romania and Expenses (in $) of San Marino?
Keep it short and to the point. 1.24e+1. In the year 2007, what is the difference between the Expenses (in $) in Bangladesh and Expenses (in $) in Lithuania?
Make the answer very short. 5.05e+1. In the year 2007, what is the difference between the Expenses (in $) of Bangladesh and Expenses (in $) of Romania?
Offer a very short reply. 3.86e+1. In the year 2007, what is the difference between the Expenses (in $) in Bangladesh and Expenses (in $) in San Marino?
Offer a terse response. 5.31e+1. In the year 2007, what is the difference between the Expenses (in $) of Lithuania and Expenses (in $) of Romania?
Give a very brief answer. -1.19e+1. In the year 2007, what is the difference between the Expenses (in $) in Lithuania and Expenses (in $) in San Marino?
Your answer should be compact. 2.55e+09. In the year 2007, what is the difference between the Expenses (in $) in Romania and Expenses (in $) in San Marino?
Your response must be concise. 1.45e+1. In the year 2008, what is the difference between the Expenses (in $) of Bangladesh and Expenses (in $) of Lithuania?
Your answer should be compact. 7.22e+1. In the year 2008, what is the difference between the Expenses (in $) in Bangladesh and Expenses (in $) in Romania?
Your response must be concise. 6.11e+1. In the year 2008, what is the difference between the Expenses (in $) of Bangladesh and Expenses (in $) of San Marino?
Provide a short and direct response. 7.46e+1. In the year 2008, what is the difference between the Expenses (in $) of Lithuania and Expenses (in $) of Romania?
Your answer should be very brief. -1.11e+1. In the year 2008, what is the difference between the Expenses (in $) in Lithuania and Expenses (in $) in San Marino?
Provide a succinct answer. 2.41e+09. In the year 2008, what is the difference between the Expenses (in $) in Romania and Expenses (in $) in San Marino?
Provide a short and direct response. 1.35e+1. In the year 2009, what is the difference between the Expenses (in $) of Bangladesh and Expenses (in $) of Lithuania?
Give a very brief answer. 8.13e+1. In the year 2009, what is the difference between the Expenses (in $) in Bangladesh and Expenses (in $) in Romania?
Provide a succinct answer. 3.66e+1. In the year 2009, what is the difference between the Expenses (in $) in Bangladesh and Expenses (in $) in San Marino?
Your answer should be compact. 8.35e+1. In the year 2009, what is the difference between the Expenses (in $) in Lithuania and Expenses (in $) in Romania?
Your answer should be very brief. -4.47e+1. In the year 2009, what is the difference between the Expenses (in $) in Lithuania and Expenses (in $) in San Marino?
Keep it short and to the point. 2.24e+09. In the year 2009, what is the difference between the Expenses (in $) in Romania and Expenses (in $) in San Marino?
Provide a short and direct response. 4.69e+1. In the year 2010, what is the difference between the Expenses (in $) in Bangladesh and Expenses (in $) in Lithuania?
Ensure brevity in your answer.  6.60e+1. In the year 2010, what is the difference between the Expenses (in $) of Bangladesh and Expenses (in $) of Romania?
Provide a succinct answer. 3.61e+1. In the year 2010, what is the difference between the Expenses (in $) of Bangladesh and Expenses (in $) of San Marino?
Offer a very short reply. 6.82e+1. In the year 2010, what is the difference between the Expenses (in $) of Lithuania and Expenses (in $) of Romania?
Give a very brief answer. -3.00e+1. In the year 2010, what is the difference between the Expenses (in $) in Lithuania and Expenses (in $) in San Marino?
Your answer should be very brief. 2.17e+09. In the year 2010, what is the difference between the Expenses (in $) of Romania and Expenses (in $) of San Marino?
Ensure brevity in your answer.  3.21e+1. What is the ratio of the Expenses (in $) in Bangladesh in 2004 to that in 2005?
Make the answer very short. 0.73. What is the ratio of the Expenses (in $) of Lithuania in 2004 to that in 2005?
Offer a very short reply. 0.87. What is the ratio of the Expenses (in $) in Romania in 2004 to that in 2005?
Offer a terse response. 0.88. What is the ratio of the Expenses (in $) of San Marino in 2004 to that in 2005?
Make the answer very short. 1.91. What is the ratio of the Expenses (in $) in Bangladesh in 2004 to that in 2006?
Make the answer very short. 0.53. What is the ratio of the Expenses (in $) in Lithuania in 2004 to that in 2006?
Keep it short and to the point. 0.86. What is the ratio of the Expenses (in $) in Romania in 2004 to that in 2006?
Your answer should be very brief. 0.56. What is the ratio of the Expenses (in $) of San Marino in 2004 to that in 2006?
Keep it short and to the point. 1.52. What is the ratio of the Expenses (in $) in Bangladesh in 2004 to that in 2007?
Offer a terse response. 0.47. What is the ratio of the Expenses (in $) of Lithuania in 2004 to that in 2007?
Your answer should be compact. 0.59. What is the ratio of the Expenses (in $) of Romania in 2004 to that in 2007?
Ensure brevity in your answer.  0.48. What is the ratio of the Expenses (in $) of San Marino in 2004 to that in 2007?
Ensure brevity in your answer.  1.61. What is the ratio of the Expenses (in $) in Bangladesh in 2004 to that in 2008?
Offer a very short reply. 0.34. What is the ratio of the Expenses (in $) of Lithuania in 2004 to that in 2008?
Your answer should be very brief. 0.63. What is the ratio of the Expenses (in $) of Romania in 2004 to that in 2008?
Offer a terse response. 0.52. What is the ratio of the Expenses (in $) in San Marino in 2004 to that in 2008?
Keep it short and to the point. 1.48. What is the ratio of the Expenses (in $) of Bangladesh in 2004 to that in 2009?
Keep it short and to the point. 0.3. What is the ratio of the Expenses (in $) in Lithuania in 2004 to that in 2009?
Offer a terse response. 0.67. What is the ratio of the Expenses (in $) in Romania in 2004 to that in 2009?
Offer a very short reply. 0.15. What is the ratio of the Expenses (in $) of San Marino in 2004 to that in 2009?
Ensure brevity in your answer.  1.36. What is the ratio of the Expenses (in $) of Bangladesh in 2004 to that in 2010?
Provide a succinct answer. 0.37. What is the ratio of the Expenses (in $) of Lithuania in 2004 to that in 2010?
Offer a very short reply. 0.69. What is the ratio of the Expenses (in $) in Romania in 2004 to that in 2010?
Keep it short and to the point. 0.22. What is the ratio of the Expenses (in $) in San Marino in 2004 to that in 2010?
Your answer should be compact. 1.41. What is the ratio of the Expenses (in $) in Bangladesh in 2005 to that in 2006?
Keep it short and to the point. 0.73. What is the ratio of the Expenses (in $) of Lithuania in 2005 to that in 2006?
Provide a succinct answer. 0.99. What is the ratio of the Expenses (in $) of Romania in 2005 to that in 2006?
Offer a terse response. 0.64. What is the ratio of the Expenses (in $) in San Marino in 2005 to that in 2006?
Keep it short and to the point. 0.79. What is the ratio of the Expenses (in $) of Bangladesh in 2005 to that in 2007?
Give a very brief answer. 0.65. What is the ratio of the Expenses (in $) of Lithuania in 2005 to that in 2007?
Make the answer very short. 0.68. What is the ratio of the Expenses (in $) of Romania in 2005 to that in 2007?
Keep it short and to the point. 0.55. What is the ratio of the Expenses (in $) of San Marino in 2005 to that in 2007?
Keep it short and to the point. 0.84. What is the ratio of the Expenses (in $) of Bangladesh in 2005 to that in 2008?
Offer a very short reply. 0.46. What is the ratio of the Expenses (in $) in Lithuania in 2005 to that in 2008?
Make the answer very short. 0.72. What is the ratio of the Expenses (in $) in Romania in 2005 to that in 2008?
Keep it short and to the point. 0.59. What is the ratio of the Expenses (in $) in San Marino in 2005 to that in 2008?
Make the answer very short. 0.77. What is the ratio of the Expenses (in $) in Bangladesh in 2005 to that in 2009?
Offer a terse response. 0.41. What is the ratio of the Expenses (in $) of Lithuania in 2005 to that in 2009?
Give a very brief answer. 0.77. What is the ratio of the Expenses (in $) of Romania in 2005 to that in 2009?
Ensure brevity in your answer.  0.17. What is the ratio of the Expenses (in $) in San Marino in 2005 to that in 2009?
Offer a very short reply. 0.71. What is the ratio of the Expenses (in $) in Bangladesh in 2005 to that in 2010?
Offer a terse response. 0.5. What is the ratio of the Expenses (in $) in Lithuania in 2005 to that in 2010?
Keep it short and to the point. 0.79. What is the ratio of the Expenses (in $) in Romania in 2005 to that in 2010?
Offer a very short reply. 0.25. What is the ratio of the Expenses (in $) of San Marino in 2005 to that in 2010?
Your response must be concise. 0.74. What is the ratio of the Expenses (in $) in Bangladesh in 2006 to that in 2007?
Ensure brevity in your answer.  0.89. What is the ratio of the Expenses (in $) in Lithuania in 2006 to that in 2007?
Provide a short and direct response. 0.69. What is the ratio of the Expenses (in $) in Romania in 2006 to that in 2007?
Ensure brevity in your answer.  0.86. What is the ratio of the Expenses (in $) of San Marino in 2006 to that in 2007?
Ensure brevity in your answer.  1.06. What is the ratio of the Expenses (in $) in Bangladesh in 2006 to that in 2008?
Your answer should be compact. 0.63. What is the ratio of the Expenses (in $) of Lithuania in 2006 to that in 2008?
Provide a short and direct response. 0.73. What is the ratio of the Expenses (in $) in Romania in 2006 to that in 2008?
Provide a succinct answer. 0.92. What is the ratio of the Expenses (in $) in San Marino in 2006 to that in 2008?
Your response must be concise. 0.98. What is the ratio of the Expenses (in $) in Bangladesh in 2006 to that in 2009?
Provide a short and direct response. 0.57. What is the ratio of the Expenses (in $) of Lithuania in 2006 to that in 2009?
Offer a terse response. 0.78. What is the ratio of the Expenses (in $) of Romania in 2006 to that in 2009?
Provide a short and direct response. 0.27. What is the ratio of the Expenses (in $) in San Marino in 2006 to that in 2009?
Provide a short and direct response. 0.9. What is the ratio of the Expenses (in $) in Bangladesh in 2006 to that in 2010?
Provide a succinct answer. 0.69. What is the ratio of the Expenses (in $) of Lithuania in 2006 to that in 2010?
Keep it short and to the point. 0.8. What is the ratio of the Expenses (in $) of Romania in 2006 to that in 2010?
Your response must be concise. 0.39. What is the ratio of the Expenses (in $) of Bangladesh in 2007 to that in 2008?
Offer a terse response. 0.71. What is the ratio of the Expenses (in $) in Lithuania in 2007 to that in 2008?
Your answer should be very brief. 1.06. What is the ratio of the Expenses (in $) of Romania in 2007 to that in 2008?
Ensure brevity in your answer.  1.07. What is the ratio of the Expenses (in $) of San Marino in 2007 to that in 2008?
Offer a very short reply. 0.92. What is the ratio of the Expenses (in $) in Bangladesh in 2007 to that in 2009?
Offer a very short reply. 0.64. What is the ratio of the Expenses (in $) of Lithuania in 2007 to that in 2009?
Your answer should be very brief. 1.13. What is the ratio of the Expenses (in $) in Romania in 2007 to that in 2009?
Offer a very short reply. 0.31. What is the ratio of the Expenses (in $) in San Marino in 2007 to that in 2009?
Offer a very short reply. 0.84. What is the ratio of the Expenses (in $) in Bangladesh in 2007 to that in 2010?
Offer a very short reply. 0.78. What is the ratio of the Expenses (in $) in Lithuania in 2007 to that in 2010?
Make the answer very short. 1.17. What is the ratio of the Expenses (in $) of Romania in 2007 to that in 2010?
Your response must be concise. 0.45. What is the ratio of the Expenses (in $) of San Marino in 2007 to that in 2010?
Provide a succinct answer. 0.87. What is the ratio of the Expenses (in $) of Bangladesh in 2008 to that in 2009?
Provide a short and direct response. 0.89. What is the ratio of the Expenses (in $) of Lithuania in 2008 to that in 2009?
Ensure brevity in your answer.  1.07. What is the ratio of the Expenses (in $) of Romania in 2008 to that in 2009?
Give a very brief answer. 0.29. What is the ratio of the Expenses (in $) of San Marino in 2008 to that in 2009?
Provide a succinct answer. 0.92. What is the ratio of the Expenses (in $) in Bangladesh in 2008 to that in 2010?
Give a very brief answer. 1.09. What is the ratio of the Expenses (in $) of Lithuania in 2008 to that in 2010?
Provide a succinct answer. 1.11. What is the ratio of the Expenses (in $) of Romania in 2008 to that in 2010?
Provide a short and direct response. 0.42. What is the ratio of the Expenses (in $) of San Marino in 2008 to that in 2010?
Your answer should be compact. 0.95. What is the ratio of the Expenses (in $) in Bangladesh in 2009 to that in 2010?
Provide a succinct answer. 1.22. What is the ratio of the Expenses (in $) in Lithuania in 2009 to that in 2010?
Offer a terse response. 1.03. What is the ratio of the Expenses (in $) in Romania in 2009 to that in 2010?
Offer a terse response. 1.46. What is the ratio of the Expenses (in $) in San Marino in 2009 to that in 2010?
Your answer should be compact. 1.04. What is the difference between the highest and the second highest Expenses (in $) in Bangladesh?
Your answer should be compact. 8.90e+09. What is the difference between the highest and the second highest Expenses (in $) of Lithuania?
Ensure brevity in your answer.  1.36e+08. What is the difference between the highest and the second highest Expenses (in $) of Romania?
Ensure brevity in your answer.  1.48e+1. What is the difference between the highest and the second highest Expenses (in $) of San Marino?
Ensure brevity in your answer.  1.49e+07. What is the difference between the highest and the lowest Expenses (in $) in Bangladesh?
Offer a terse response. 5.84e+1. What is the difference between the highest and the lowest Expenses (in $) of Lithuania?
Offer a very short reply. 1.05e+09. What is the difference between the highest and the lowest Expenses (in $) in Romania?
Keep it short and to the point. 4.00e+1. What is the difference between the highest and the lowest Expenses (in $) of San Marino?
Provide a short and direct response. 2.70e+07. 